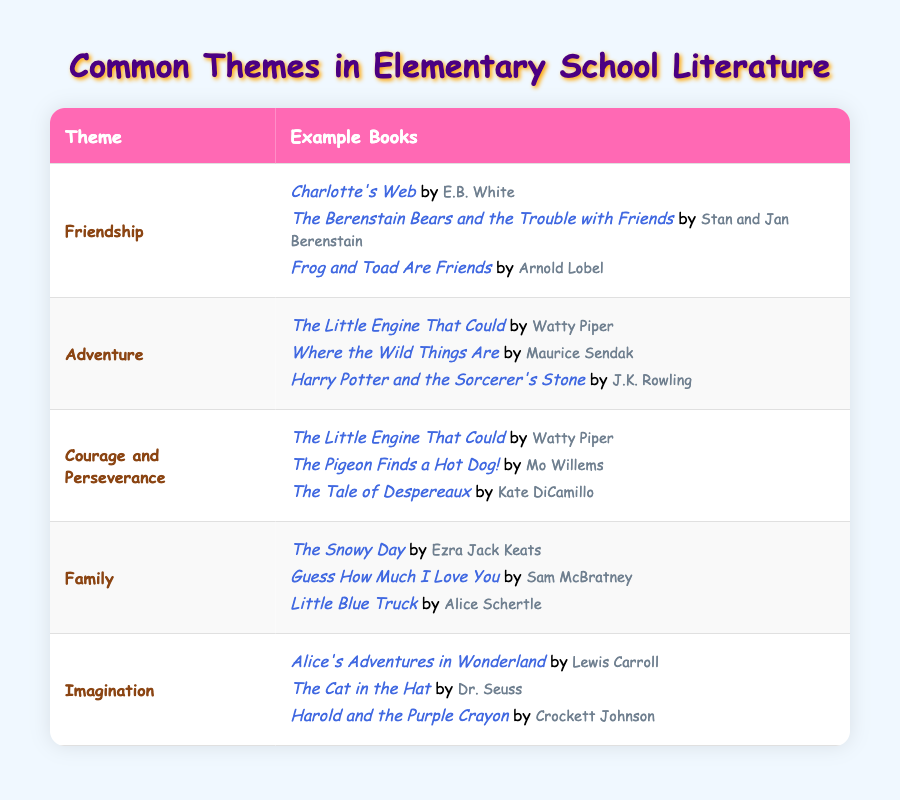What theme has the most example books listed? The table shows that "Friendship," "Adventure," "Courage and Perseverance," "Family," and "Imagination" each have three example books listed under them. Since they all have the same number, there is a tie between all five themes in terms of the number of example books.
Answer: Friendship, Adventure, Courage and Perseverance, Family, Imagination Which theme has a book by E.B. White? The table lists "Friendship" as one of the themes, and under "Friendship," it shows "Charlotte's Web" by E.B. White as an example book.
Answer: Friendship Is "Where the Wild Things Are" about Family? Looking at the table, "Where the Wild Things Are" is listed under the theme "Adventure," so it is not about Family.
Answer: No How many themes include the book "The Little Engine That Could"? The book "The Little Engine That Could" appears twice in the table, listed under both "Adventure" and "Courage and Perseverance." This shows that it fits in two themes.
Answer: 2 Are all themes represented by three example books? Each theme listed ("Friendship," "Adventure," "Courage and Perseverance," "Family," and "Imagination") has exactly three example books associated with it. Therefore, all themes are indeed represented by the same number of example books.
Answer: Yes 